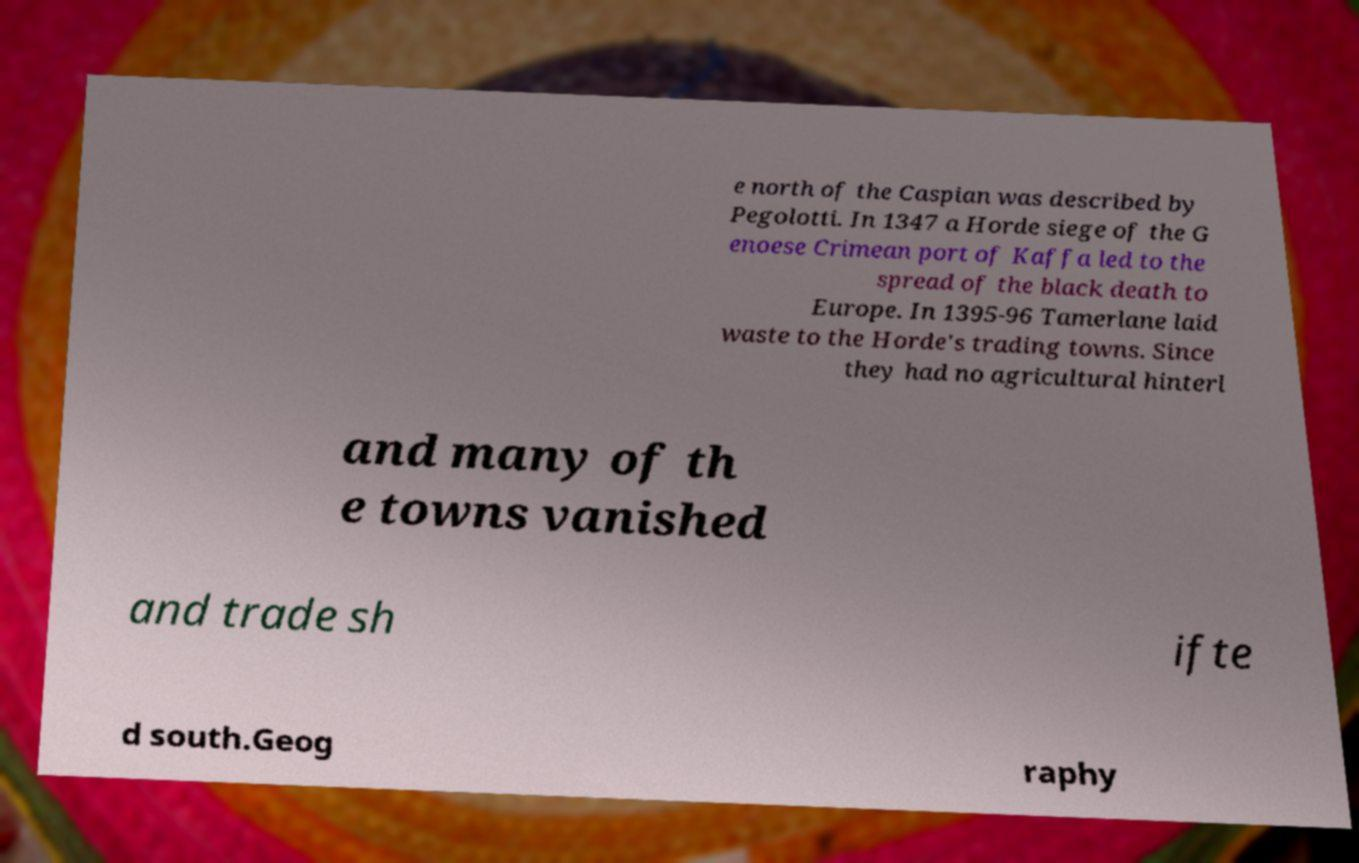Can you accurately transcribe the text from the provided image for me? e north of the Caspian was described by Pegolotti. In 1347 a Horde siege of the G enoese Crimean port of Kaffa led to the spread of the black death to Europe. In 1395-96 Tamerlane laid waste to the Horde's trading towns. Since they had no agricultural hinterl and many of th e towns vanished and trade sh ifte d south.Geog raphy 